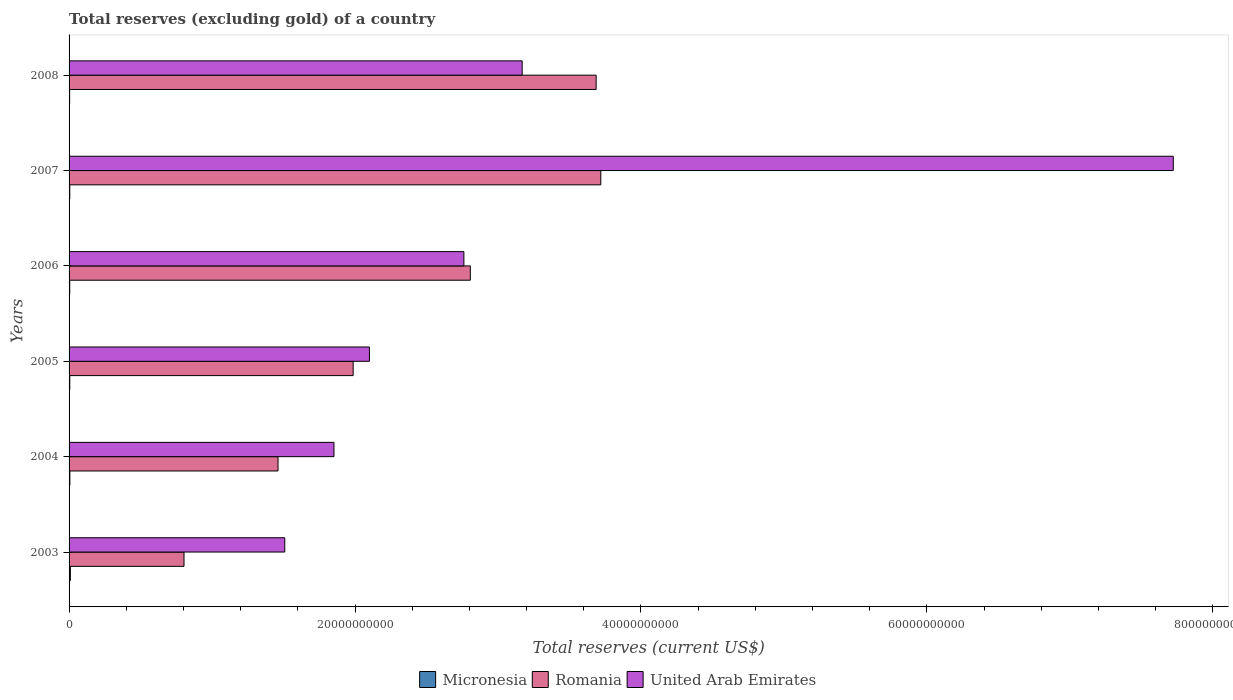How many different coloured bars are there?
Your answer should be very brief. 3. How many groups of bars are there?
Keep it short and to the point. 6. Are the number of bars per tick equal to the number of legend labels?
Make the answer very short. Yes. How many bars are there on the 1st tick from the top?
Your response must be concise. 3. How many bars are there on the 5th tick from the bottom?
Make the answer very short. 3. In how many cases, is the number of bars for a given year not equal to the number of legend labels?
Provide a short and direct response. 0. What is the total reserves (excluding gold) in Romania in 2006?
Make the answer very short. 2.81e+1. Across all years, what is the maximum total reserves (excluding gold) in Romania?
Give a very brief answer. 3.72e+1. Across all years, what is the minimum total reserves (excluding gold) in Micronesia?
Your answer should be compact. 4.00e+07. In which year was the total reserves (excluding gold) in Micronesia minimum?
Your answer should be compact. 2008. What is the total total reserves (excluding gold) in Micronesia in the graph?
Your response must be concise. 3.29e+08. What is the difference between the total reserves (excluding gold) in Micronesia in 2007 and that in 2008?
Keep it short and to the point. 8.49e+06. What is the difference between the total reserves (excluding gold) in Romania in 2004 and the total reserves (excluding gold) in Micronesia in 2005?
Offer a very short reply. 1.46e+1. What is the average total reserves (excluding gold) in Romania per year?
Offer a very short reply. 2.41e+1. In the year 2005, what is the difference between the total reserves (excluding gold) in United Arab Emirates and total reserves (excluding gold) in Micronesia?
Make the answer very short. 2.10e+1. What is the ratio of the total reserves (excluding gold) in Romania in 2004 to that in 2006?
Ensure brevity in your answer.  0.52. Is the difference between the total reserves (excluding gold) in United Arab Emirates in 2003 and 2006 greater than the difference between the total reserves (excluding gold) in Micronesia in 2003 and 2006?
Offer a terse response. No. What is the difference between the highest and the second highest total reserves (excluding gold) in Romania?
Your answer should be compact. 3.26e+08. What is the difference between the highest and the lowest total reserves (excluding gold) in United Arab Emirates?
Make the answer very short. 6.22e+1. In how many years, is the total reserves (excluding gold) in United Arab Emirates greater than the average total reserves (excluding gold) in United Arab Emirates taken over all years?
Offer a terse response. 1. What does the 2nd bar from the top in 2005 represents?
Provide a short and direct response. Romania. What does the 3rd bar from the bottom in 2004 represents?
Offer a very short reply. United Arab Emirates. Is it the case that in every year, the sum of the total reserves (excluding gold) in United Arab Emirates and total reserves (excluding gold) in Micronesia is greater than the total reserves (excluding gold) in Romania?
Offer a terse response. No. How many bars are there?
Ensure brevity in your answer.  18. Are all the bars in the graph horizontal?
Your response must be concise. Yes. What is the difference between two consecutive major ticks on the X-axis?
Your answer should be very brief. 2.00e+1. Does the graph contain any zero values?
Keep it short and to the point. No. What is the title of the graph?
Your answer should be compact. Total reserves (excluding gold) of a country. What is the label or title of the X-axis?
Your answer should be compact. Total reserves (current US$). What is the Total reserves (current US$) in Micronesia in 2003?
Keep it short and to the point. 8.96e+07. What is the Total reserves (current US$) in Romania in 2003?
Your answer should be very brief. 8.04e+09. What is the Total reserves (current US$) in United Arab Emirates in 2003?
Offer a very short reply. 1.51e+1. What is the Total reserves (current US$) of Micronesia in 2004?
Your answer should be compact. 5.48e+07. What is the Total reserves (current US$) of Romania in 2004?
Ensure brevity in your answer.  1.46e+1. What is the Total reserves (current US$) of United Arab Emirates in 2004?
Ensure brevity in your answer.  1.85e+1. What is the Total reserves (current US$) of Micronesia in 2005?
Your answer should be compact. 5.00e+07. What is the Total reserves (current US$) in Romania in 2005?
Your response must be concise. 1.99e+1. What is the Total reserves (current US$) of United Arab Emirates in 2005?
Ensure brevity in your answer.  2.10e+1. What is the Total reserves (current US$) in Micronesia in 2006?
Your response must be concise. 4.66e+07. What is the Total reserves (current US$) of Romania in 2006?
Offer a very short reply. 2.81e+1. What is the Total reserves (current US$) in United Arab Emirates in 2006?
Your answer should be very brief. 2.76e+1. What is the Total reserves (current US$) of Micronesia in 2007?
Your answer should be compact. 4.85e+07. What is the Total reserves (current US$) of Romania in 2007?
Ensure brevity in your answer.  3.72e+1. What is the Total reserves (current US$) in United Arab Emirates in 2007?
Offer a terse response. 7.72e+1. What is the Total reserves (current US$) in Micronesia in 2008?
Ensure brevity in your answer.  4.00e+07. What is the Total reserves (current US$) of Romania in 2008?
Give a very brief answer. 3.69e+1. What is the Total reserves (current US$) in United Arab Emirates in 2008?
Make the answer very short. 3.17e+1. Across all years, what is the maximum Total reserves (current US$) in Micronesia?
Your answer should be very brief. 8.96e+07. Across all years, what is the maximum Total reserves (current US$) of Romania?
Your answer should be very brief. 3.72e+1. Across all years, what is the maximum Total reserves (current US$) in United Arab Emirates?
Offer a terse response. 7.72e+1. Across all years, what is the minimum Total reserves (current US$) of Micronesia?
Make the answer very short. 4.00e+07. Across all years, what is the minimum Total reserves (current US$) of Romania?
Give a very brief answer. 8.04e+09. Across all years, what is the minimum Total reserves (current US$) in United Arab Emirates?
Provide a succinct answer. 1.51e+1. What is the total Total reserves (current US$) in Micronesia in the graph?
Your response must be concise. 3.29e+08. What is the total Total reserves (current US$) of Romania in the graph?
Give a very brief answer. 1.45e+11. What is the total Total reserves (current US$) of United Arab Emirates in the graph?
Your response must be concise. 1.91e+11. What is the difference between the Total reserves (current US$) in Micronesia in 2003 and that in 2004?
Provide a succinct answer. 3.48e+07. What is the difference between the Total reserves (current US$) in Romania in 2003 and that in 2004?
Keep it short and to the point. -6.58e+09. What is the difference between the Total reserves (current US$) in United Arab Emirates in 2003 and that in 2004?
Keep it short and to the point. -3.44e+09. What is the difference between the Total reserves (current US$) of Micronesia in 2003 and that in 2005?
Make the answer very short. 3.97e+07. What is the difference between the Total reserves (current US$) in Romania in 2003 and that in 2005?
Make the answer very short. -1.18e+1. What is the difference between the Total reserves (current US$) in United Arab Emirates in 2003 and that in 2005?
Offer a very short reply. -5.92e+09. What is the difference between the Total reserves (current US$) of Micronesia in 2003 and that in 2006?
Provide a succinct answer. 4.30e+07. What is the difference between the Total reserves (current US$) of Romania in 2003 and that in 2006?
Give a very brief answer. -2.00e+1. What is the difference between the Total reserves (current US$) in United Arab Emirates in 2003 and that in 2006?
Offer a very short reply. -1.25e+1. What is the difference between the Total reserves (current US$) of Micronesia in 2003 and that in 2007?
Give a very brief answer. 4.11e+07. What is the difference between the Total reserves (current US$) in Romania in 2003 and that in 2007?
Offer a terse response. -2.92e+1. What is the difference between the Total reserves (current US$) in United Arab Emirates in 2003 and that in 2007?
Give a very brief answer. -6.22e+1. What is the difference between the Total reserves (current US$) in Micronesia in 2003 and that in 2008?
Give a very brief answer. 4.96e+07. What is the difference between the Total reserves (current US$) of Romania in 2003 and that in 2008?
Your response must be concise. -2.88e+1. What is the difference between the Total reserves (current US$) in United Arab Emirates in 2003 and that in 2008?
Your answer should be very brief. -1.66e+1. What is the difference between the Total reserves (current US$) of Micronesia in 2004 and that in 2005?
Keep it short and to the point. 4.89e+06. What is the difference between the Total reserves (current US$) in Romania in 2004 and that in 2005?
Offer a very short reply. -5.26e+09. What is the difference between the Total reserves (current US$) in United Arab Emirates in 2004 and that in 2005?
Your response must be concise. -2.48e+09. What is the difference between the Total reserves (current US$) of Micronesia in 2004 and that in 2006?
Offer a very short reply. 8.22e+06. What is the difference between the Total reserves (current US$) of Romania in 2004 and that in 2006?
Provide a succinct answer. -1.34e+1. What is the difference between the Total reserves (current US$) in United Arab Emirates in 2004 and that in 2006?
Provide a succinct answer. -9.09e+09. What is the difference between the Total reserves (current US$) in Micronesia in 2004 and that in 2007?
Your answer should be very brief. 6.36e+06. What is the difference between the Total reserves (current US$) of Romania in 2004 and that in 2007?
Your answer should be compact. -2.26e+1. What is the difference between the Total reserves (current US$) in United Arab Emirates in 2004 and that in 2007?
Give a very brief answer. -5.87e+1. What is the difference between the Total reserves (current US$) of Micronesia in 2004 and that in 2008?
Give a very brief answer. 1.49e+07. What is the difference between the Total reserves (current US$) of Romania in 2004 and that in 2008?
Offer a very short reply. -2.23e+1. What is the difference between the Total reserves (current US$) of United Arab Emirates in 2004 and that in 2008?
Your response must be concise. -1.32e+1. What is the difference between the Total reserves (current US$) of Micronesia in 2005 and that in 2006?
Your response must be concise. 3.33e+06. What is the difference between the Total reserves (current US$) of Romania in 2005 and that in 2006?
Ensure brevity in your answer.  -8.19e+09. What is the difference between the Total reserves (current US$) of United Arab Emirates in 2005 and that in 2006?
Make the answer very short. -6.61e+09. What is the difference between the Total reserves (current US$) of Micronesia in 2005 and that in 2007?
Provide a short and direct response. 1.47e+06. What is the difference between the Total reserves (current US$) of Romania in 2005 and that in 2007?
Make the answer very short. -1.73e+1. What is the difference between the Total reserves (current US$) in United Arab Emirates in 2005 and that in 2007?
Provide a succinct answer. -5.62e+1. What is the difference between the Total reserves (current US$) of Micronesia in 2005 and that in 2008?
Make the answer very short. 9.97e+06. What is the difference between the Total reserves (current US$) of Romania in 2005 and that in 2008?
Your response must be concise. -1.70e+1. What is the difference between the Total reserves (current US$) in United Arab Emirates in 2005 and that in 2008?
Your response must be concise. -1.07e+1. What is the difference between the Total reserves (current US$) of Micronesia in 2006 and that in 2007?
Provide a succinct answer. -1.86e+06. What is the difference between the Total reserves (current US$) of Romania in 2006 and that in 2007?
Give a very brief answer. -9.13e+09. What is the difference between the Total reserves (current US$) in United Arab Emirates in 2006 and that in 2007?
Offer a terse response. -4.96e+1. What is the difference between the Total reserves (current US$) of Micronesia in 2006 and that in 2008?
Offer a very short reply. 6.64e+06. What is the difference between the Total reserves (current US$) in Romania in 2006 and that in 2008?
Your response must be concise. -8.80e+09. What is the difference between the Total reserves (current US$) of United Arab Emirates in 2006 and that in 2008?
Your response must be concise. -4.08e+09. What is the difference between the Total reserves (current US$) in Micronesia in 2007 and that in 2008?
Offer a terse response. 8.49e+06. What is the difference between the Total reserves (current US$) in Romania in 2007 and that in 2008?
Offer a very short reply. 3.26e+08. What is the difference between the Total reserves (current US$) in United Arab Emirates in 2007 and that in 2008?
Give a very brief answer. 4.55e+1. What is the difference between the Total reserves (current US$) in Micronesia in 2003 and the Total reserves (current US$) in Romania in 2004?
Offer a terse response. -1.45e+1. What is the difference between the Total reserves (current US$) in Micronesia in 2003 and the Total reserves (current US$) in United Arab Emirates in 2004?
Make the answer very short. -1.84e+1. What is the difference between the Total reserves (current US$) of Romania in 2003 and the Total reserves (current US$) of United Arab Emirates in 2004?
Provide a succinct answer. -1.05e+1. What is the difference between the Total reserves (current US$) of Micronesia in 2003 and the Total reserves (current US$) of Romania in 2005?
Your response must be concise. -1.98e+1. What is the difference between the Total reserves (current US$) of Micronesia in 2003 and the Total reserves (current US$) of United Arab Emirates in 2005?
Provide a succinct answer. -2.09e+1. What is the difference between the Total reserves (current US$) in Romania in 2003 and the Total reserves (current US$) in United Arab Emirates in 2005?
Provide a short and direct response. -1.30e+1. What is the difference between the Total reserves (current US$) in Micronesia in 2003 and the Total reserves (current US$) in Romania in 2006?
Your answer should be compact. -2.80e+1. What is the difference between the Total reserves (current US$) of Micronesia in 2003 and the Total reserves (current US$) of United Arab Emirates in 2006?
Your answer should be very brief. -2.75e+1. What is the difference between the Total reserves (current US$) in Romania in 2003 and the Total reserves (current US$) in United Arab Emirates in 2006?
Your response must be concise. -1.96e+1. What is the difference between the Total reserves (current US$) in Micronesia in 2003 and the Total reserves (current US$) in Romania in 2007?
Make the answer very short. -3.71e+1. What is the difference between the Total reserves (current US$) in Micronesia in 2003 and the Total reserves (current US$) in United Arab Emirates in 2007?
Provide a short and direct response. -7.71e+1. What is the difference between the Total reserves (current US$) of Romania in 2003 and the Total reserves (current US$) of United Arab Emirates in 2007?
Provide a succinct answer. -6.92e+1. What is the difference between the Total reserves (current US$) in Micronesia in 2003 and the Total reserves (current US$) in Romania in 2008?
Your answer should be very brief. -3.68e+1. What is the difference between the Total reserves (current US$) of Micronesia in 2003 and the Total reserves (current US$) of United Arab Emirates in 2008?
Your answer should be compact. -3.16e+1. What is the difference between the Total reserves (current US$) in Romania in 2003 and the Total reserves (current US$) in United Arab Emirates in 2008?
Your response must be concise. -2.37e+1. What is the difference between the Total reserves (current US$) in Micronesia in 2004 and the Total reserves (current US$) in Romania in 2005?
Your answer should be compact. -1.98e+1. What is the difference between the Total reserves (current US$) of Micronesia in 2004 and the Total reserves (current US$) of United Arab Emirates in 2005?
Your answer should be very brief. -2.10e+1. What is the difference between the Total reserves (current US$) of Romania in 2004 and the Total reserves (current US$) of United Arab Emirates in 2005?
Provide a short and direct response. -6.39e+09. What is the difference between the Total reserves (current US$) in Micronesia in 2004 and the Total reserves (current US$) in Romania in 2006?
Give a very brief answer. -2.80e+1. What is the difference between the Total reserves (current US$) of Micronesia in 2004 and the Total reserves (current US$) of United Arab Emirates in 2006?
Provide a succinct answer. -2.76e+1. What is the difference between the Total reserves (current US$) of Romania in 2004 and the Total reserves (current US$) of United Arab Emirates in 2006?
Ensure brevity in your answer.  -1.30e+1. What is the difference between the Total reserves (current US$) of Micronesia in 2004 and the Total reserves (current US$) of Romania in 2007?
Your answer should be compact. -3.71e+1. What is the difference between the Total reserves (current US$) in Micronesia in 2004 and the Total reserves (current US$) in United Arab Emirates in 2007?
Provide a short and direct response. -7.72e+1. What is the difference between the Total reserves (current US$) in Romania in 2004 and the Total reserves (current US$) in United Arab Emirates in 2007?
Give a very brief answer. -6.26e+1. What is the difference between the Total reserves (current US$) of Micronesia in 2004 and the Total reserves (current US$) of Romania in 2008?
Keep it short and to the point. -3.68e+1. What is the difference between the Total reserves (current US$) of Micronesia in 2004 and the Total reserves (current US$) of United Arab Emirates in 2008?
Your answer should be very brief. -3.16e+1. What is the difference between the Total reserves (current US$) in Romania in 2004 and the Total reserves (current US$) in United Arab Emirates in 2008?
Provide a succinct answer. -1.71e+1. What is the difference between the Total reserves (current US$) of Micronesia in 2005 and the Total reserves (current US$) of Romania in 2006?
Your answer should be very brief. -2.80e+1. What is the difference between the Total reserves (current US$) in Micronesia in 2005 and the Total reserves (current US$) in United Arab Emirates in 2006?
Offer a very short reply. -2.76e+1. What is the difference between the Total reserves (current US$) of Romania in 2005 and the Total reserves (current US$) of United Arab Emirates in 2006?
Your answer should be very brief. -7.75e+09. What is the difference between the Total reserves (current US$) in Micronesia in 2005 and the Total reserves (current US$) in Romania in 2007?
Give a very brief answer. -3.71e+1. What is the difference between the Total reserves (current US$) in Micronesia in 2005 and the Total reserves (current US$) in United Arab Emirates in 2007?
Ensure brevity in your answer.  -7.72e+1. What is the difference between the Total reserves (current US$) in Romania in 2005 and the Total reserves (current US$) in United Arab Emirates in 2007?
Give a very brief answer. -5.74e+1. What is the difference between the Total reserves (current US$) of Micronesia in 2005 and the Total reserves (current US$) of Romania in 2008?
Provide a succinct answer. -3.68e+1. What is the difference between the Total reserves (current US$) in Micronesia in 2005 and the Total reserves (current US$) in United Arab Emirates in 2008?
Offer a very short reply. -3.16e+1. What is the difference between the Total reserves (current US$) of Romania in 2005 and the Total reserves (current US$) of United Arab Emirates in 2008?
Your answer should be compact. -1.18e+1. What is the difference between the Total reserves (current US$) in Micronesia in 2006 and the Total reserves (current US$) in Romania in 2007?
Keep it short and to the point. -3.71e+1. What is the difference between the Total reserves (current US$) of Micronesia in 2006 and the Total reserves (current US$) of United Arab Emirates in 2007?
Offer a very short reply. -7.72e+1. What is the difference between the Total reserves (current US$) in Romania in 2006 and the Total reserves (current US$) in United Arab Emirates in 2007?
Give a very brief answer. -4.92e+1. What is the difference between the Total reserves (current US$) in Micronesia in 2006 and the Total reserves (current US$) in Romania in 2008?
Give a very brief answer. -3.68e+1. What is the difference between the Total reserves (current US$) of Micronesia in 2006 and the Total reserves (current US$) of United Arab Emirates in 2008?
Offer a very short reply. -3.16e+1. What is the difference between the Total reserves (current US$) in Romania in 2006 and the Total reserves (current US$) in United Arab Emirates in 2008?
Make the answer very short. -3.63e+09. What is the difference between the Total reserves (current US$) in Micronesia in 2007 and the Total reserves (current US$) in Romania in 2008?
Keep it short and to the point. -3.68e+1. What is the difference between the Total reserves (current US$) in Micronesia in 2007 and the Total reserves (current US$) in United Arab Emirates in 2008?
Keep it short and to the point. -3.16e+1. What is the difference between the Total reserves (current US$) of Romania in 2007 and the Total reserves (current US$) of United Arab Emirates in 2008?
Ensure brevity in your answer.  5.50e+09. What is the average Total reserves (current US$) of Micronesia per year?
Your answer should be compact. 5.49e+07. What is the average Total reserves (current US$) in Romania per year?
Give a very brief answer. 2.41e+1. What is the average Total reserves (current US$) of United Arab Emirates per year?
Make the answer very short. 3.19e+1. In the year 2003, what is the difference between the Total reserves (current US$) of Micronesia and Total reserves (current US$) of Romania?
Make the answer very short. -7.95e+09. In the year 2003, what is the difference between the Total reserves (current US$) of Micronesia and Total reserves (current US$) of United Arab Emirates?
Make the answer very short. -1.50e+1. In the year 2003, what is the difference between the Total reserves (current US$) in Romania and Total reserves (current US$) in United Arab Emirates?
Your response must be concise. -7.05e+09. In the year 2004, what is the difference between the Total reserves (current US$) in Micronesia and Total reserves (current US$) in Romania?
Offer a terse response. -1.46e+1. In the year 2004, what is the difference between the Total reserves (current US$) of Micronesia and Total reserves (current US$) of United Arab Emirates?
Offer a very short reply. -1.85e+1. In the year 2004, what is the difference between the Total reserves (current US$) of Romania and Total reserves (current US$) of United Arab Emirates?
Your answer should be compact. -3.91e+09. In the year 2005, what is the difference between the Total reserves (current US$) in Micronesia and Total reserves (current US$) in Romania?
Your answer should be compact. -1.98e+1. In the year 2005, what is the difference between the Total reserves (current US$) of Micronesia and Total reserves (current US$) of United Arab Emirates?
Give a very brief answer. -2.10e+1. In the year 2005, what is the difference between the Total reserves (current US$) of Romania and Total reserves (current US$) of United Arab Emirates?
Your response must be concise. -1.14e+09. In the year 2006, what is the difference between the Total reserves (current US$) in Micronesia and Total reserves (current US$) in Romania?
Your answer should be compact. -2.80e+1. In the year 2006, what is the difference between the Total reserves (current US$) in Micronesia and Total reserves (current US$) in United Arab Emirates?
Your answer should be very brief. -2.76e+1. In the year 2006, what is the difference between the Total reserves (current US$) in Romania and Total reserves (current US$) in United Arab Emirates?
Keep it short and to the point. 4.49e+08. In the year 2007, what is the difference between the Total reserves (current US$) of Micronesia and Total reserves (current US$) of Romania?
Your answer should be compact. -3.71e+1. In the year 2007, what is the difference between the Total reserves (current US$) in Micronesia and Total reserves (current US$) in United Arab Emirates?
Offer a very short reply. -7.72e+1. In the year 2007, what is the difference between the Total reserves (current US$) of Romania and Total reserves (current US$) of United Arab Emirates?
Give a very brief answer. -4.00e+1. In the year 2008, what is the difference between the Total reserves (current US$) of Micronesia and Total reserves (current US$) of Romania?
Your response must be concise. -3.68e+1. In the year 2008, what is the difference between the Total reserves (current US$) in Micronesia and Total reserves (current US$) in United Arab Emirates?
Provide a short and direct response. -3.17e+1. In the year 2008, what is the difference between the Total reserves (current US$) of Romania and Total reserves (current US$) of United Arab Emirates?
Keep it short and to the point. 5.17e+09. What is the ratio of the Total reserves (current US$) in Micronesia in 2003 to that in 2004?
Offer a terse response. 1.63. What is the ratio of the Total reserves (current US$) of Romania in 2003 to that in 2004?
Offer a very short reply. 0.55. What is the ratio of the Total reserves (current US$) in United Arab Emirates in 2003 to that in 2004?
Provide a short and direct response. 0.81. What is the ratio of the Total reserves (current US$) in Micronesia in 2003 to that in 2005?
Make the answer very short. 1.79. What is the ratio of the Total reserves (current US$) of Romania in 2003 to that in 2005?
Provide a short and direct response. 0.4. What is the ratio of the Total reserves (current US$) in United Arab Emirates in 2003 to that in 2005?
Your answer should be very brief. 0.72. What is the ratio of the Total reserves (current US$) of Micronesia in 2003 to that in 2006?
Keep it short and to the point. 1.92. What is the ratio of the Total reserves (current US$) of Romania in 2003 to that in 2006?
Your response must be concise. 0.29. What is the ratio of the Total reserves (current US$) of United Arab Emirates in 2003 to that in 2006?
Your response must be concise. 0.55. What is the ratio of the Total reserves (current US$) of Micronesia in 2003 to that in 2007?
Your response must be concise. 1.85. What is the ratio of the Total reserves (current US$) of Romania in 2003 to that in 2007?
Ensure brevity in your answer.  0.22. What is the ratio of the Total reserves (current US$) of United Arab Emirates in 2003 to that in 2007?
Your answer should be compact. 0.2. What is the ratio of the Total reserves (current US$) in Micronesia in 2003 to that in 2008?
Provide a short and direct response. 2.24. What is the ratio of the Total reserves (current US$) in Romania in 2003 to that in 2008?
Keep it short and to the point. 0.22. What is the ratio of the Total reserves (current US$) in United Arab Emirates in 2003 to that in 2008?
Provide a succinct answer. 0.48. What is the ratio of the Total reserves (current US$) in Micronesia in 2004 to that in 2005?
Provide a succinct answer. 1.1. What is the ratio of the Total reserves (current US$) in Romania in 2004 to that in 2005?
Offer a very short reply. 0.74. What is the ratio of the Total reserves (current US$) in United Arab Emirates in 2004 to that in 2005?
Your answer should be compact. 0.88. What is the ratio of the Total reserves (current US$) of Micronesia in 2004 to that in 2006?
Give a very brief answer. 1.18. What is the ratio of the Total reserves (current US$) in Romania in 2004 to that in 2006?
Make the answer very short. 0.52. What is the ratio of the Total reserves (current US$) in United Arab Emirates in 2004 to that in 2006?
Offer a very short reply. 0.67. What is the ratio of the Total reserves (current US$) of Micronesia in 2004 to that in 2007?
Ensure brevity in your answer.  1.13. What is the ratio of the Total reserves (current US$) of Romania in 2004 to that in 2007?
Offer a very short reply. 0.39. What is the ratio of the Total reserves (current US$) in United Arab Emirates in 2004 to that in 2007?
Provide a succinct answer. 0.24. What is the ratio of the Total reserves (current US$) of Micronesia in 2004 to that in 2008?
Your answer should be compact. 1.37. What is the ratio of the Total reserves (current US$) of Romania in 2004 to that in 2008?
Your answer should be very brief. 0.4. What is the ratio of the Total reserves (current US$) in United Arab Emirates in 2004 to that in 2008?
Provide a succinct answer. 0.58. What is the ratio of the Total reserves (current US$) of Micronesia in 2005 to that in 2006?
Your response must be concise. 1.07. What is the ratio of the Total reserves (current US$) in Romania in 2005 to that in 2006?
Your answer should be very brief. 0.71. What is the ratio of the Total reserves (current US$) in United Arab Emirates in 2005 to that in 2006?
Make the answer very short. 0.76. What is the ratio of the Total reserves (current US$) of Micronesia in 2005 to that in 2007?
Your answer should be very brief. 1.03. What is the ratio of the Total reserves (current US$) of Romania in 2005 to that in 2007?
Your answer should be very brief. 0.53. What is the ratio of the Total reserves (current US$) in United Arab Emirates in 2005 to that in 2007?
Provide a short and direct response. 0.27. What is the ratio of the Total reserves (current US$) in Micronesia in 2005 to that in 2008?
Offer a terse response. 1.25. What is the ratio of the Total reserves (current US$) in Romania in 2005 to that in 2008?
Ensure brevity in your answer.  0.54. What is the ratio of the Total reserves (current US$) in United Arab Emirates in 2005 to that in 2008?
Give a very brief answer. 0.66. What is the ratio of the Total reserves (current US$) of Micronesia in 2006 to that in 2007?
Your answer should be very brief. 0.96. What is the ratio of the Total reserves (current US$) in Romania in 2006 to that in 2007?
Provide a succinct answer. 0.75. What is the ratio of the Total reserves (current US$) of United Arab Emirates in 2006 to that in 2007?
Your answer should be very brief. 0.36. What is the ratio of the Total reserves (current US$) of Micronesia in 2006 to that in 2008?
Your answer should be very brief. 1.17. What is the ratio of the Total reserves (current US$) in Romania in 2006 to that in 2008?
Your answer should be very brief. 0.76. What is the ratio of the Total reserves (current US$) in United Arab Emirates in 2006 to that in 2008?
Offer a very short reply. 0.87. What is the ratio of the Total reserves (current US$) of Micronesia in 2007 to that in 2008?
Keep it short and to the point. 1.21. What is the ratio of the Total reserves (current US$) of Romania in 2007 to that in 2008?
Your answer should be very brief. 1.01. What is the ratio of the Total reserves (current US$) of United Arab Emirates in 2007 to that in 2008?
Provide a succinct answer. 2.44. What is the difference between the highest and the second highest Total reserves (current US$) in Micronesia?
Provide a succinct answer. 3.48e+07. What is the difference between the highest and the second highest Total reserves (current US$) in Romania?
Keep it short and to the point. 3.26e+08. What is the difference between the highest and the second highest Total reserves (current US$) in United Arab Emirates?
Make the answer very short. 4.55e+1. What is the difference between the highest and the lowest Total reserves (current US$) in Micronesia?
Offer a very short reply. 4.96e+07. What is the difference between the highest and the lowest Total reserves (current US$) in Romania?
Offer a very short reply. 2.92e+1. What is the difference between the highest and the lowest Total reserves (current US$) of United Arab Emirates?
Your response must be concise. 6.22e+1. 